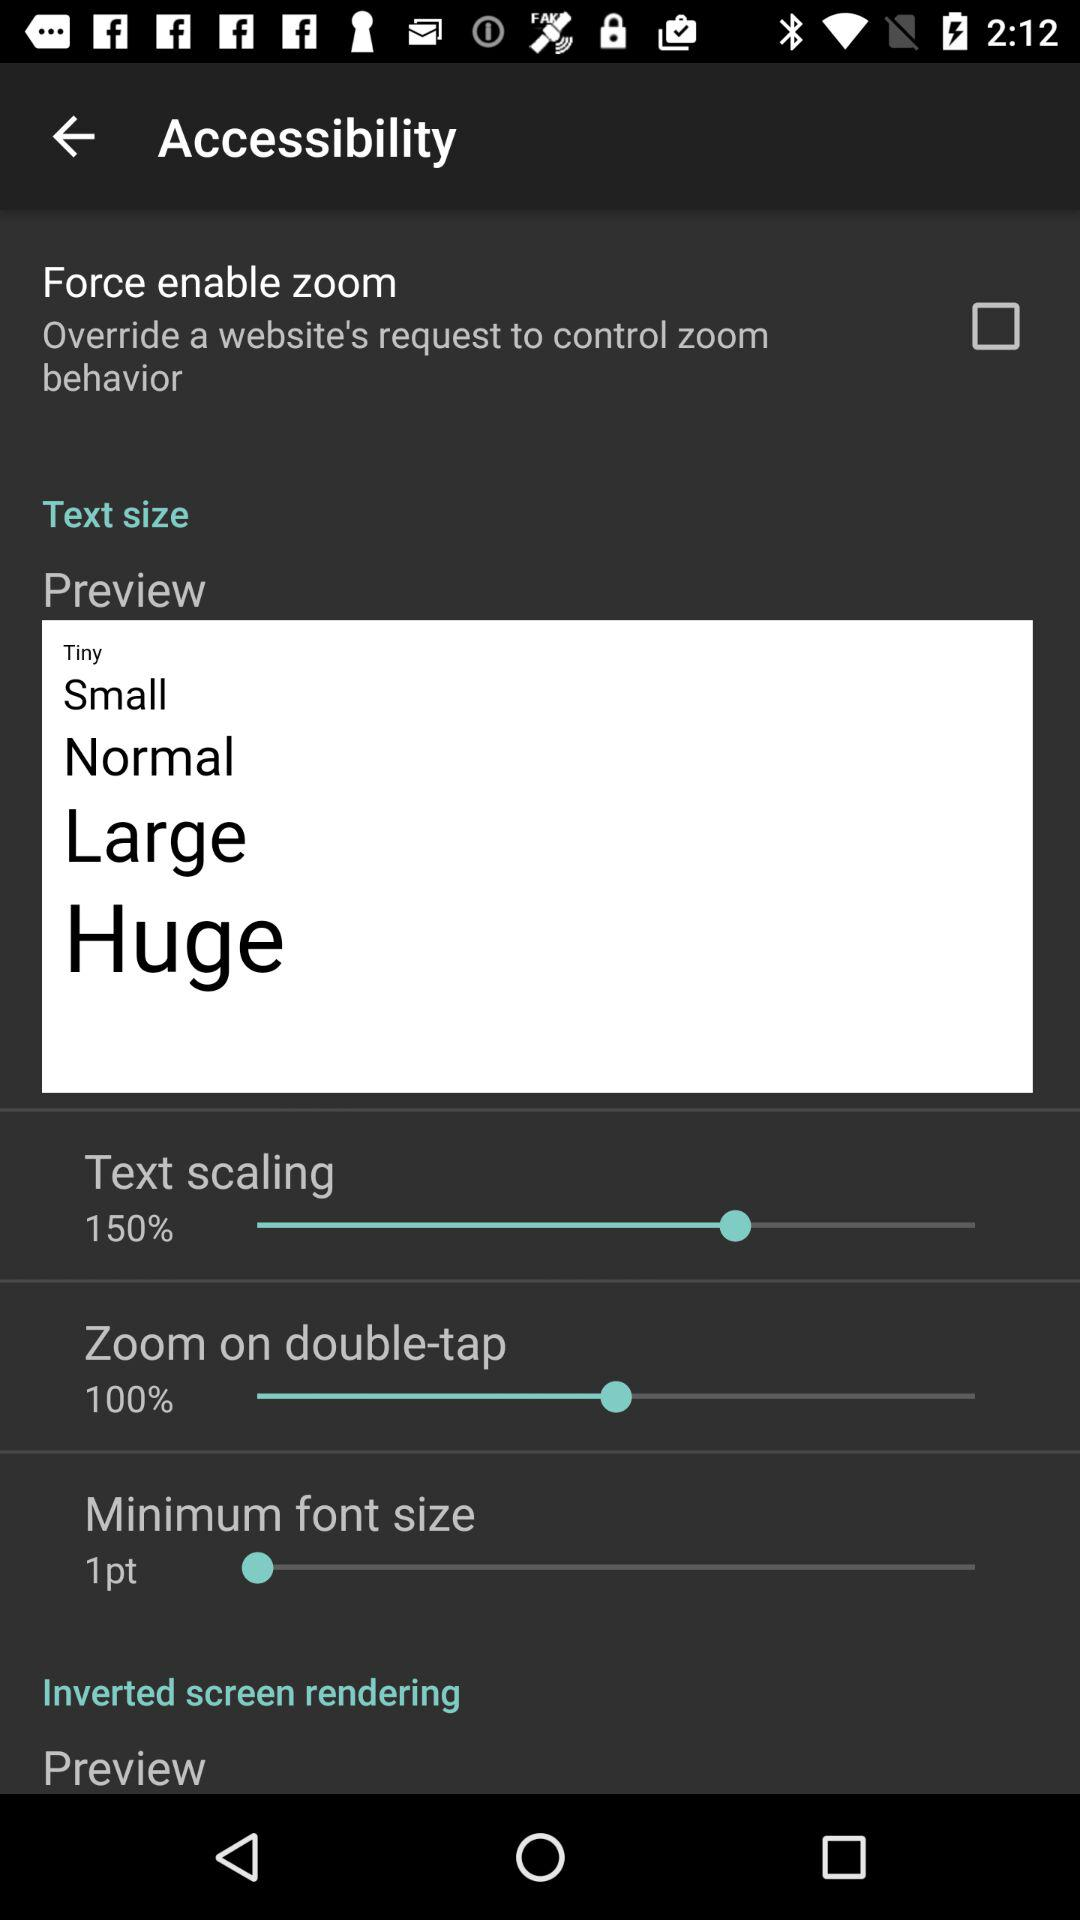How many text sizes are available?
Answer the question using a single word or phrase. 5 